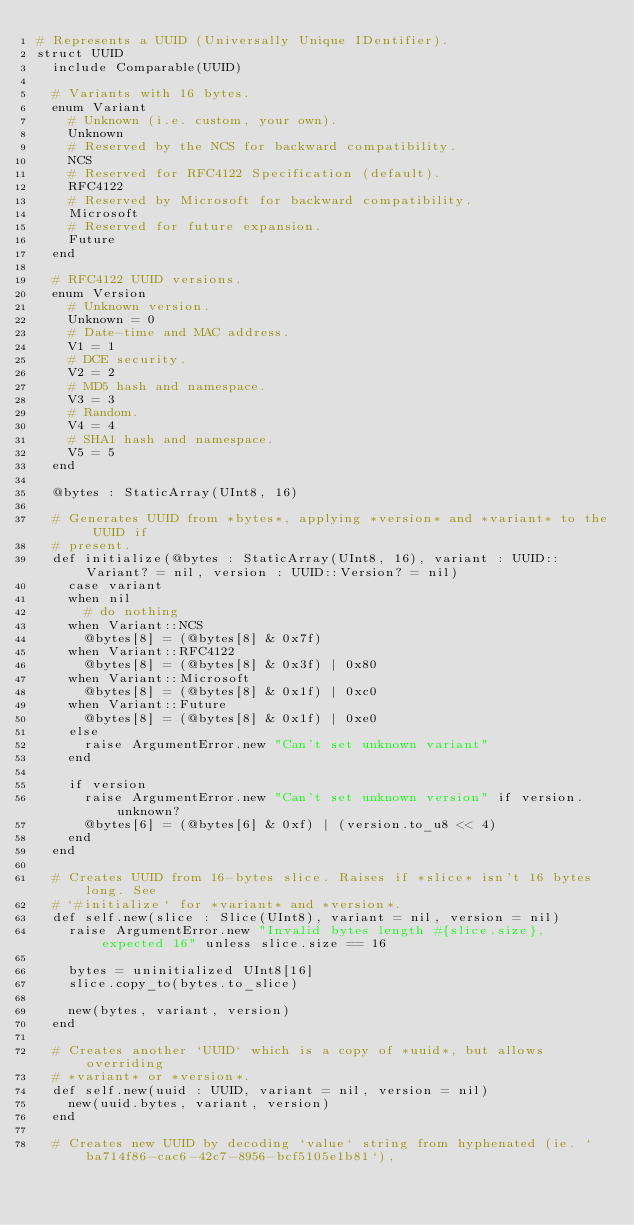Convert code to text. <code><loc_0><loc_0><loc_500><loc_500><_Crystal_># Represents a UUID (Universally Unique IDentifier).
struct UUID
  include Comparable(UUID)

  # Variants with 16 bytes.
  enum Variant
    # Unknown (i.e. custom, your own).
    Unknown
    # Reserved by the NCS for backward compatibility.
    NCS
    # Reserved for RFC4122 Specification (default).
    RFC4122
    # Reserved by Microsoft for backward compatibility.
    Microsoft
    # Reserved for future expansion.
    Future
  end

  # RFC4122 UUID versions.
  enum Version
    # Unknown version.
    Unknown = 0
    # Date-time and MAC address.
    V1 = 1
    # DCE security.
    V2 = 2
    # MD5 hash and namespace.
    V3 = 3
    # Random.
    V4 = 4
    # SHA1 hash and namespace.
    V5 = 5
  end

  @bytes : StaticArray(UInt8, 16)

  # Generates UUID from *bytes*, applying *version* and *variant* to the UUID if
  # present.
  def initialize(@bytes : StaticArray(UInt8, 16), variant : UUID::Variant? = nil, version : UUID::Version? = nil)
    case variant
    when nil
      # do nothing
    when Variant::NCS
      @bytes[8] = (@bytes[8] & 0x7f)
    when Variant::RFC4122
      @bytes[8] = (@bytes[8] & 0x3f) | 0x80
    when Variant::Microsoft
      @bytes[8] = (@bytes[8] & 0x1f) | 0xc0
    when Variant::Future
      @bytes[8] = (@bytes[8] & 0x1f) | 0xe0
    else
      raise ArgumentError.new "Can't set unknown variant"
    end

    if version
      raise ArgumentError.new "Can't set unknown version" if version.unknown?
      @bytes[6] = (@bytes[6] & 0xf) | (version.to_u8 << 4)
    end
  end

  # Creates UUID from 16-bytes slice. Raises if *slice* isn't 16 bytes long. See
  # `#initialize` for *variant* and *version*.
  def self.new(slice : Slice(UInt8), variant = nil, version = nil)
    raise ArgumentError.new "Invalid bytes length #{slice.size}, expected 16" unless slice.size == 16

    bytes = uninitialized UInt8[16]
    slice.copy_to(bytes.to_slice)

    new(bytes, variant, version)
  end

  # Creates another `UUID` which is a copy of *uuid*, but allows overriding
  # *variant* or *version*.
  def self.new(uuid : UUID, variant = nil, version = nil)
    new(uuid.bytes, variant, version)
  end

  # Creates new UUID by decoding `value` string from hyphenated (ie. `ba714f86-cac6-42c7-8956-bcf5105e1b81`),</code> 